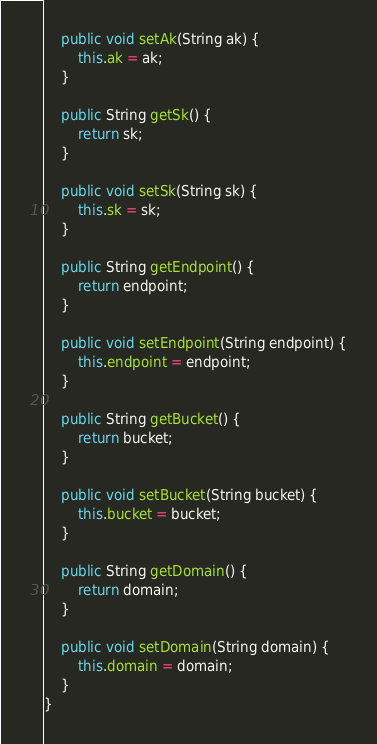<code> <loc_0><loc_0><loc_500><loc_500><_Java_>    public void setAk(String ak) {
        this.ak = ak;
    }

    public String getSk() {
        return sk;
    }

    public void setSk(String sk) {
        this.sk = sk;
    }

    public String getEndpoint() {
        return endpoint;
    }

    public void setEndpoint(String endpoint) {
        this.endpoint = endpoint;
    }

    public String getBucket() {
        return bucket;
    }

    public void setBucket(String bucket) {
        this.bucket = bucket;
    }

    public String getDomain() {
        return domain;
    }

    public void setDomain(String domain) {
        this.domain = domain;
    }
}
</code> 